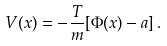<formula> <loc_0><loc_0><loc_500><loc_500>V ( { x } ) = - \frac { T } { m } [ \Phi ( { x } ) - a ] \, .</formula> 